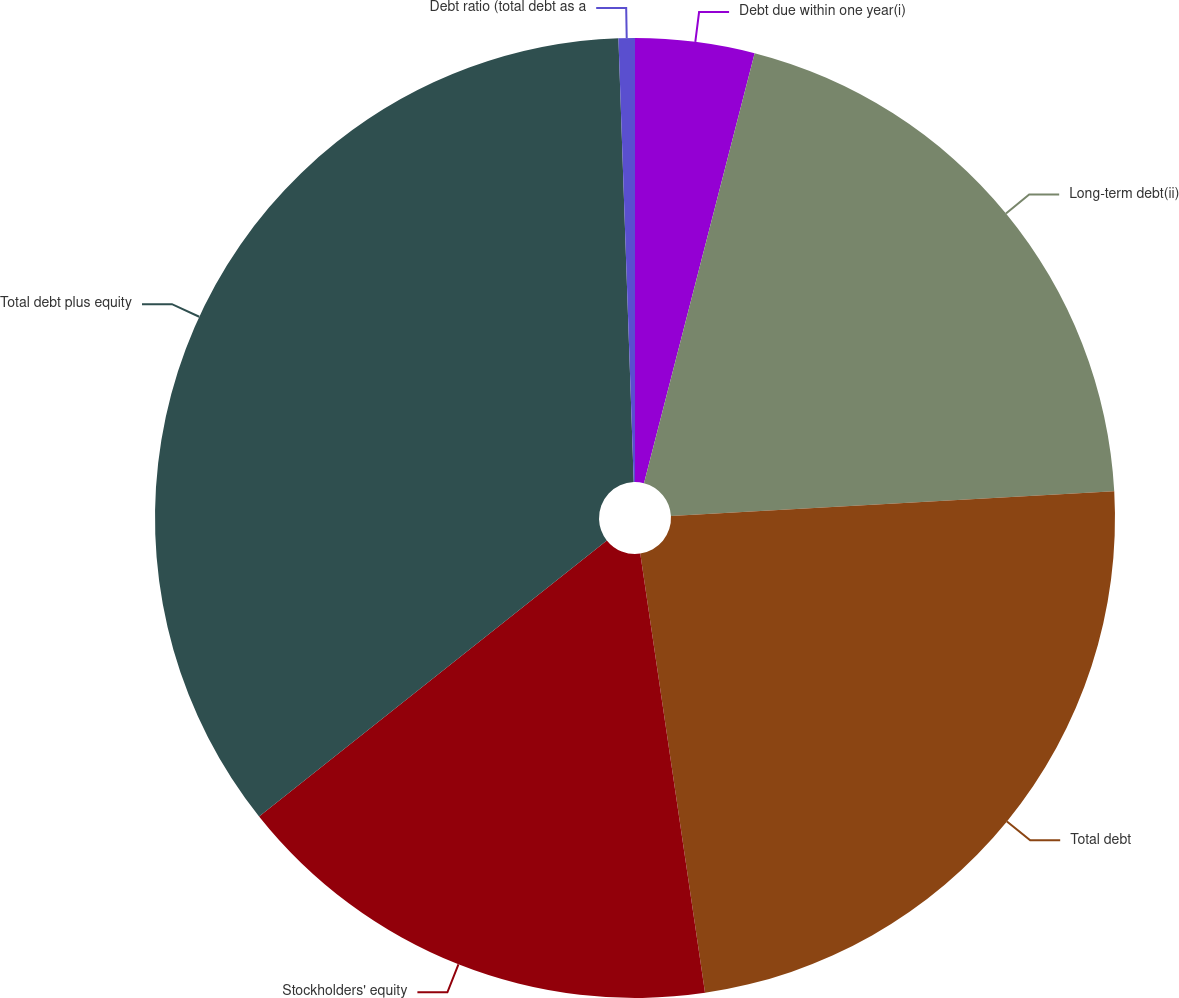Convert chart to OTSL. <chart><loc_0><loc_0><loc_500><loc_500><pie_chart><fcel>Debt due within one year(i)<fcel>Long-term debt(ii)<fcel>Total debt<fcel>Stockholders' equity<fcel>Total debt plus equity<fcel>Debt ratio (total debt as a<nl><fcel>4.01%<fcel>20.1%<fcel>23.56%<fcel>16.65%<fcel>35.13%<fcel>0.55%<nl></chart> 